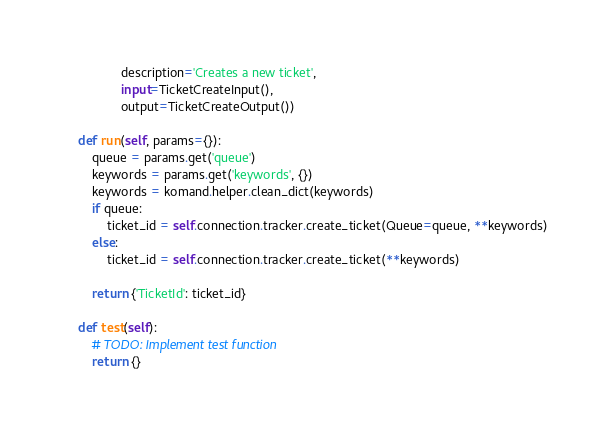<code> <loc_0><loc_0><loc_500><loc_500><_Python_>                description='Creates a new ticket',
                input=TicketCreateInput(),
                output=TicketCreateOutput())

    def run(self, params={}):
        queue = params.get('queue')
        keywords = params.get('keywords', {})
        keywords = komand.helper.clean_dict(keywords)
        if queue:
            ticket_id = self.connection.tracker.create_ticket(Queue=queue, **keywords)
        else:
            ticket_id = self.connection.tracker.create_ticket(**keywords)

        return {'TicketId': ticket_id}

    def test(self):
        # TODO: Implement test function
        return {}
</code> 